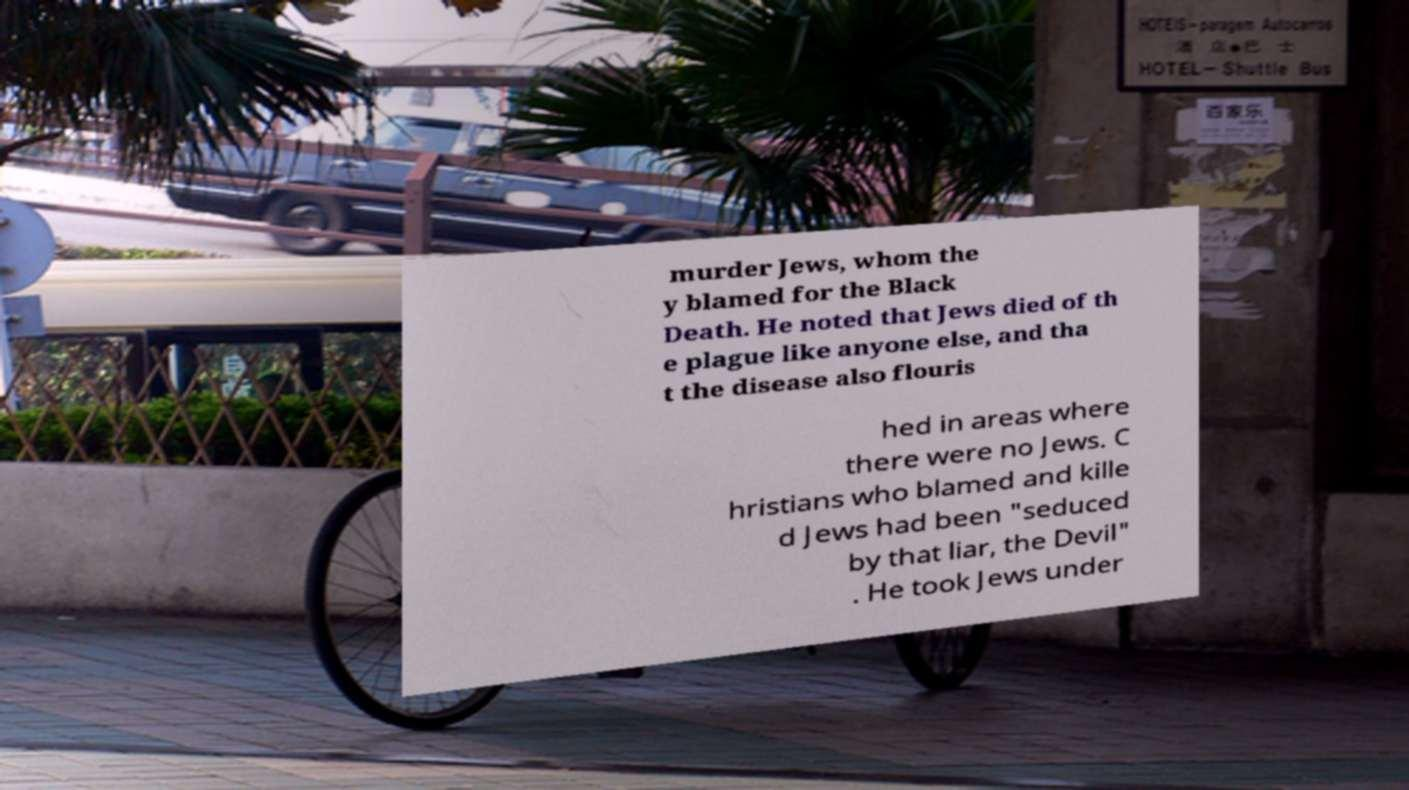Please read and relay the text visible in this image. What does it say? murder Jews, whom the y blamed for the Black Death. He noted that Jews died of th e plague like anyone else, and tha t the disease also flouris hed in areas where there were no Jews. C hristians who blamed and kille d Jews had been "seduced by that liar, the Devil" . He took Jews under 